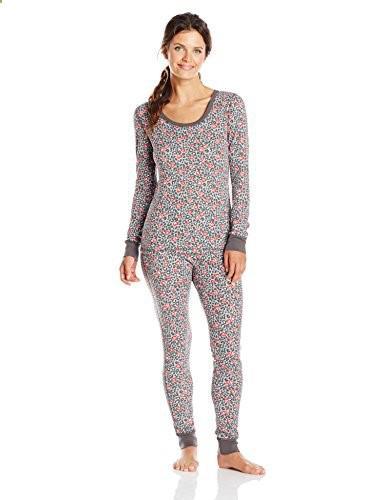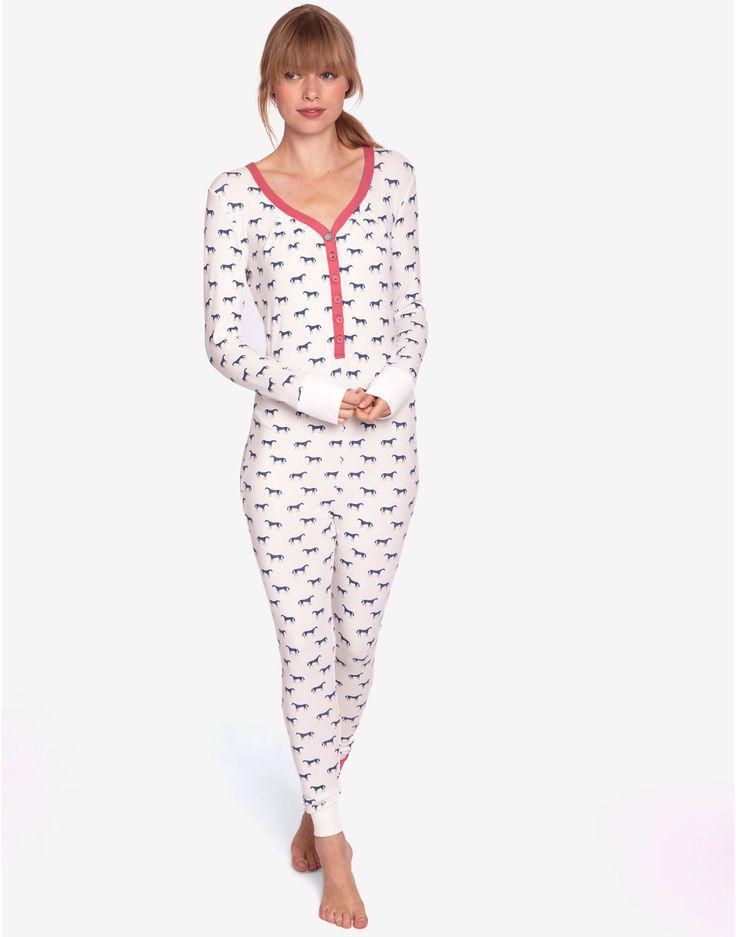The first image is the image on the left, the second image is the image on the right. Considering the images on both sides, is "One pair of pajamas has red trim around the neck and the ankles." valid? Answer yes or no. No. The first image is the image on the left, the second image is the image on the right. Assess this claim about the two images: "Some of the pajamas are one piece and all of them have skin tight legs.". Correct or not? Answer yes or no. Yes. The first image is the image on the left, the second image is the image on the right. Considering the images on both sides, is "The girl on the left is wearing primarily gray pajamas." valid? Answer yes or no. Yes. The first image is the image on the left, the second image is the image on the right. Evaluate the accuracy of this statement regarding the images: "All of the girls are brunettes.". Is it true? Answer yes or no. No. 